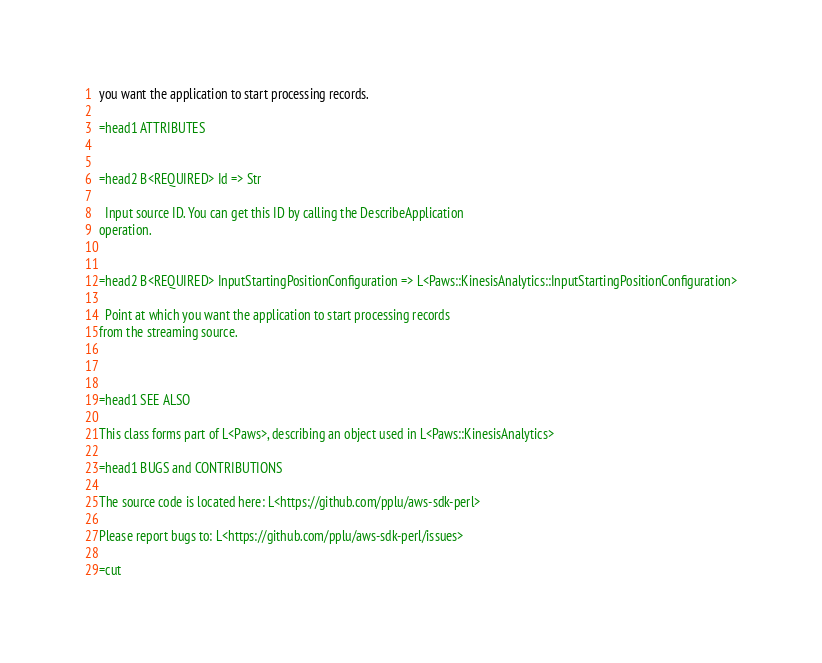<code> <loc_0><loc_0><loc_500><loc_500><_Perl_>you want the application to start processing records.

=head1 ATTRIBUTES


=head2 B<REQUIRED> Id => Str

  Input source ID. You can get this ID by calling the DescribeApplication
operation.


=head2 B<REQUIRED> InputStartingPositionConfiguration => L<Paws::KinesisAnalytics::InputStartingPositionConfiguration>

  Point at which you want the application to start processing records
from the streaming source.



=head1 SEE ALSO

This class forms part of L<Paws>, describing an object used in L<Paws::KinesisAnalytics>

=head1 BUGS and CONTRIBUTIONS

The source code is located here: L<https://github.com/pplu/aws-sdk-perl>

Please report bugs to: L<https://github.com/pplu/aws-sdk-perl/issues>

=cut

</code> 